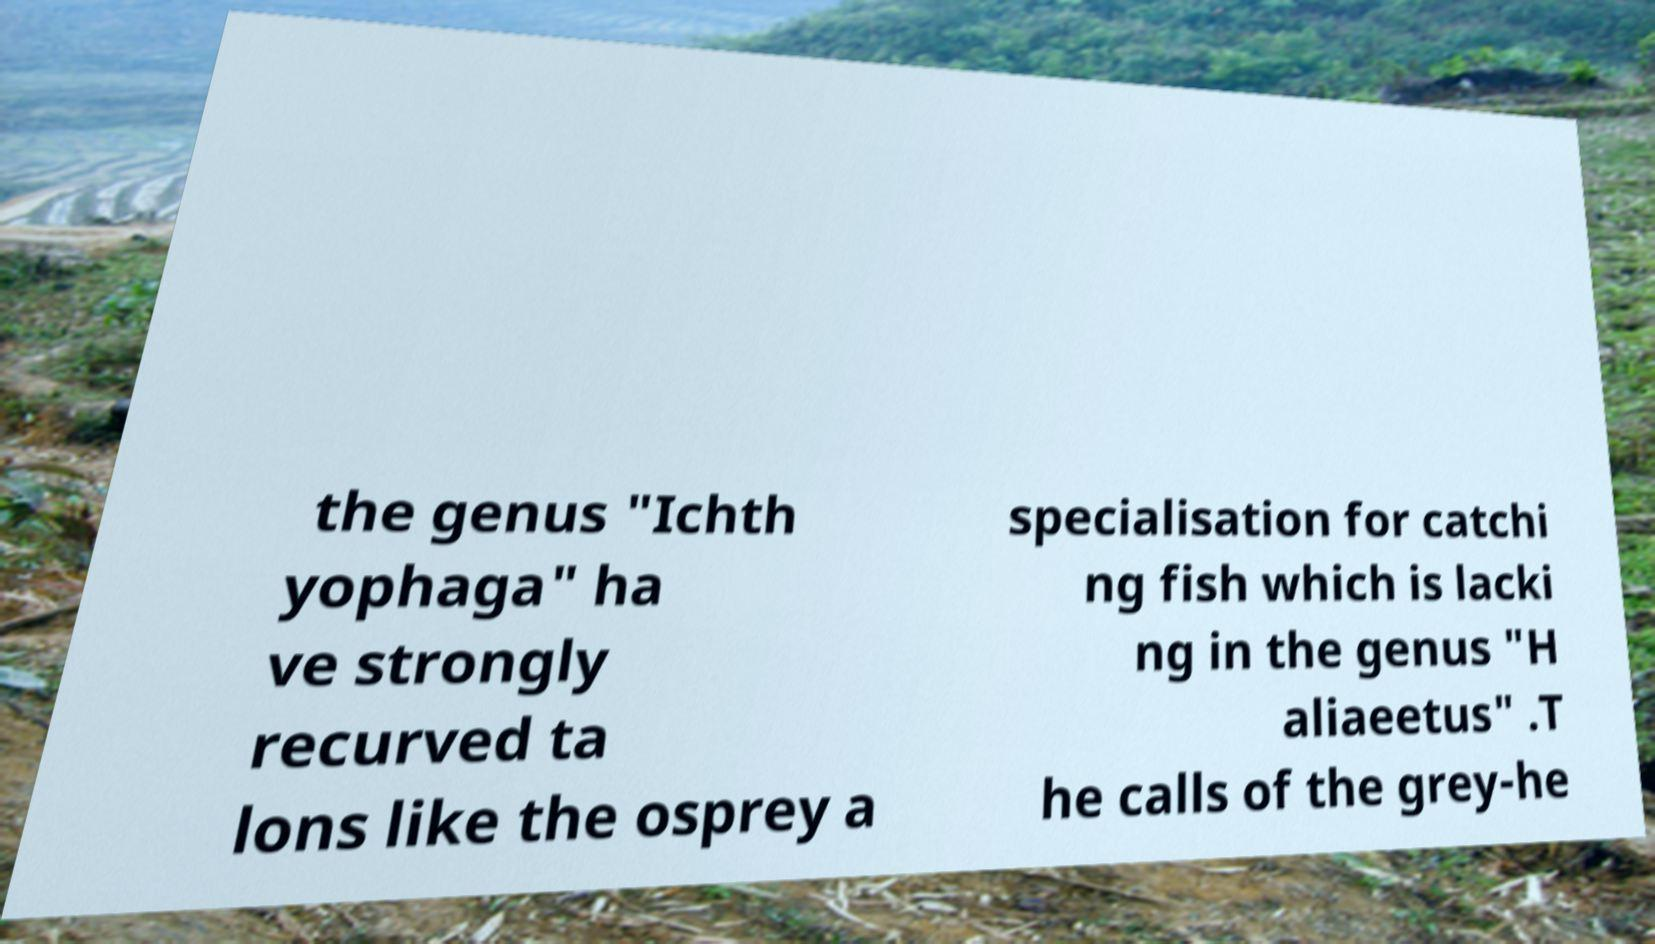For documentation purposes, I need the text within this image transcribed. Could you provide that? the genus "Ichth yophaga" ha ve strongly recurved ta lons like the osprey a specialisation for catchi ng fish which is lacki ng in the genus "H aliaeetus" .T he calls of the grey-he 